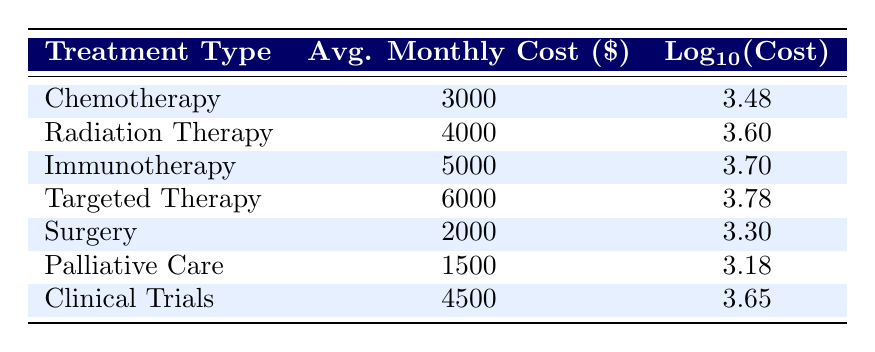What is the average monthly cost of chemotherapy? The table shows that the average monthly cost for chemotherapy is listed directly under the corresponding treatment type.
Answer: 3000 What is the log base 10 of the average monthly cost for targeted therapy? The table indicates that the log base 10 of the average monthly cost for targeted therapy is provided in the third column. It shows a value of 3.78.
Answer: 3.78 Is the average monthly cost for palliation care less than that for surgery? The average monthly cost for palliative care is 1500, while for surgery it is 2000. Since 1500 is less than 2000, the answer is yes.
Answer: Yes What is the total average monthly cost for all treatment types listed? To find the total average monthly cost, sum up all the average costs from the table: (3000 + 4000 + 5000 + 6000 + 2000 + 1500 + 4500) = 27000, so the total is 27000.
Answer: 27000 What is the median of the average monthly costs for the treatments listed? First, list the average monthly costs in ascending order: 1500, 2000, 3000, 4000, 4500, 5000, 6000. There are seven values, the median is the fourth one in this case, which is 4000.
Answer: 4000 Which treatment type has the highest average monthly cost? By comparing the average monthly costs from the table, targeted therapy at 6000 has the highest value among all the treatments listed.
Answer: Targeted Therapy Is the average monthly cost of clinical trials greater than that of immunotherapy? The average monthly cost for clinical trials is 4500, and for immunotherapy, it is 5000. Since 4500 is not greater than 5000, the answer is no.
Answer: No What is the average of the logarithmic costs for all treatment types? First, calculate the logarithmic values listed: (3.48 + 3.60 + 3.70 + 3.78 + 3.30 + 3.18 + 3.65) = 24.19. There are seven treatments, so the average is 24.19 / 7 ≈ 3.45.
Answer: 3.45 What is the difference between the highest and lowest average monthly costs? The highest average monthly cost is for targeted therapy at 6000, and the lowest is for palliative care at 1500. The difference is 6000 - 1500 = 4500.
Answer: 4500 